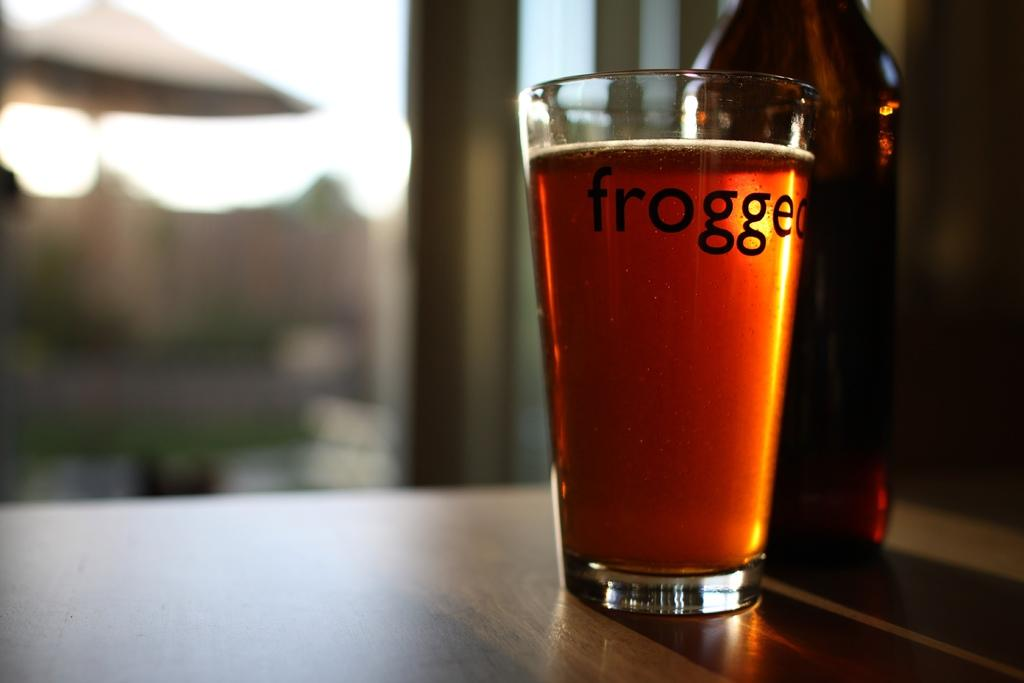Provide a one-sentence caption for the provided image. A full glass with a label frogged on it. 